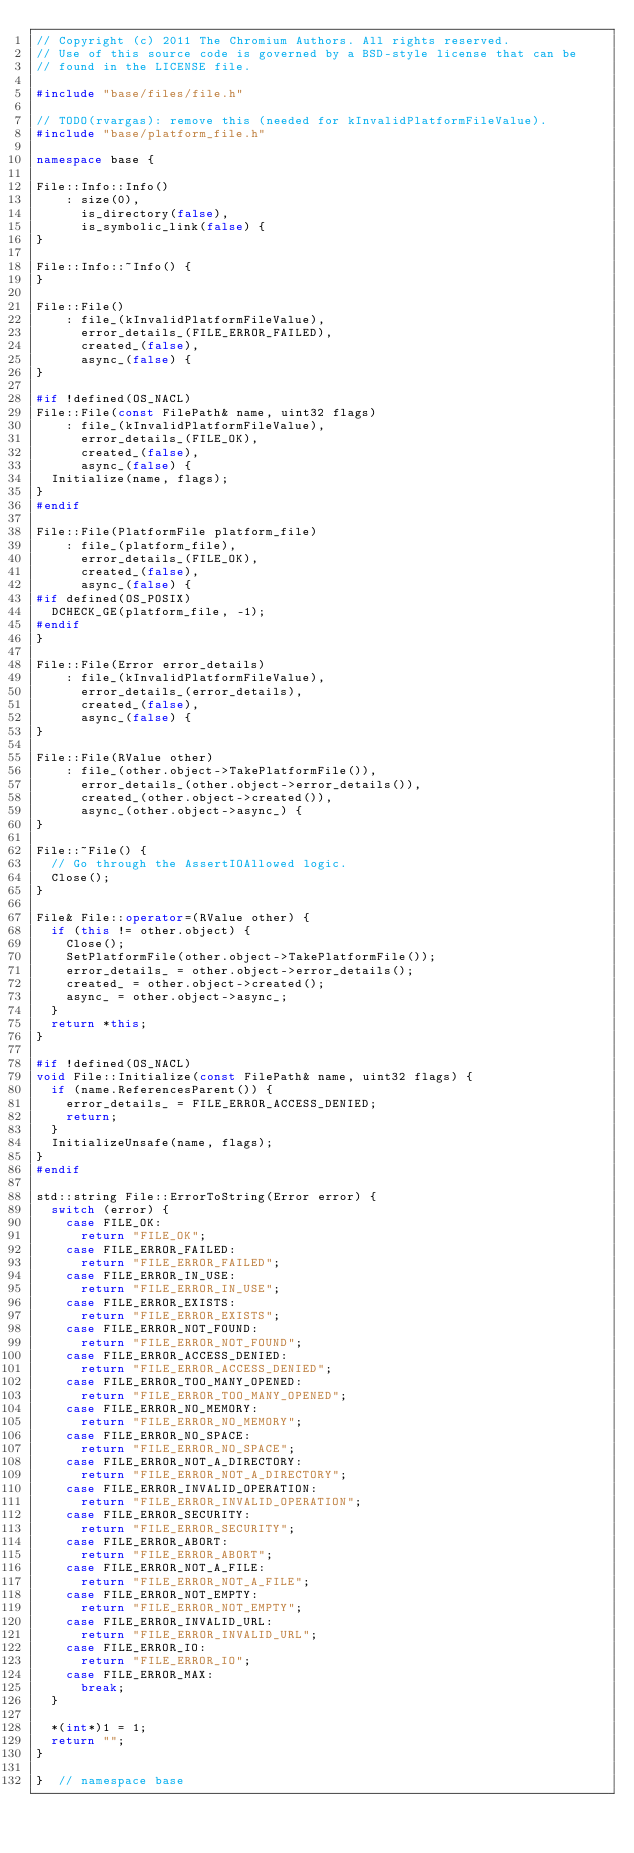<code> <loc_0><loc_0><loc_500><loc_500><_C++_>// Copyright (c) 2011 The Chromium Authors. All rights reserved.
// Use of this source code is governed by a BSD-style license that can be
// found in the LICENSE file.

#include "base/files/file.h"

// TODO(rvargas): remove this (needed for kInvalidPlatformFileValue).
#include "base/platform_file.h"

namespace base {

File::Info::Info()
    : size(0),
      is_directory(false),
      is_symbolic_link(false) {
}

File::Info::~Info() {
}

File::File()
    : file_(kInvalidPlatformFileValue),
      error_details_(FILE_ERROR_FAILED),
      created_(false),
      async_(false) {
}

#if !defined(OS_NACL)
File::File(const FilePath& name, uint32 flags)
    : file_(kInvalidPlatformFileValue),
      error_details_(FILE_OK),
      created_(false),
      async_(false) {
  Initialize(name, flags);
}
#endif

File::File(PlatformFile platform_file)
    : file_(platform_file),
      error_details_(FILE_OK),
      created_(false),
      async_(false) {
#if defined(OS_POSIX)
  DCHECK_GE(platform_file, -1);
#endif
}

File::File(Error error_details)
    : file_(kInvalidPlatformFileValue),
      error_details_(error_details),
      created_(false),
      async_(false) {
}

File::File(RValue other)
    : file_(other.object->TakePlatformFile()),
      error_details_(other.object->error_details()),
      created_(other.object->created()),
      async_(other.object->async_) {
}

File::~File() {
  // Go through the AssertIOAllowed logic.
  Close();
}

File& File::operator=(RValue other) {
  if (this != other.object) {
    Close();
    SetPlatformFile(other.object->TakePlatformFile());
    error_details_ = other.object->error_details();
    created_ = other.object->created();
    async_ = other.object->async_;
  }
  return *this;
}

#if !defined(OS_NACL)
void File::Initialize(const FilePath& name, uint32 flags) {
  if (name.ReferencesParent()) {
    error_details_ = FILE_ERROR_ACCESS_DENIED;
    return;
  }
  InitializeUnsafe(name, flags);
}
#endif

std::string File::ErrorToString(Error error) {
  switch (error) {
    case FILE_OK:
      return "FILE_OK";
    case FILE_ERROR_FAILED:
      return "FILE_ERROR_FAILED";
    case FILE_ERROR_IN_USE:
      return "FILE_ERROR_IN_USE";
    case FILE_ERROR_EXISTS:
      return "FILE_ERROR_EXISTS";
    case FILE_ERROR_NOT_FOUND:
      return "FILE_ERROR_NOT_FOUND";
    case FILE_ERROR_ACCESS_DENIED:
      return "FILE_ERROR_ACCESS_DENIED";
    case FILE_ERROR_TOO_MANY_OPENED:
      return "FILE_ERROR_TOO_MANY_OPENED";
    case FILE_ERROR_NO_MEMORY:
      return "FILE_ERROR_NO_MEMORY";
    case FILE_ERROR_NO_SPACE:
      return "FILE_ERROR_NO_SPACE";
    case FILE_ERROR_NOT_A_DIRECTORY:
      return "FILE_ERROR_NOT_A_DIRECTORY";
    case FILE_ERROR_INVALID_OPERATION:
      return "FILE_ERROR_INVALID_OPERATION";
    case FILE_ERROR_SECURITY:
      return "FILE_ERROR_SECURITY";
    case FILE_ERROR_ABORT:
      return "FILE_ERROR_ABORT";
    case FILE_ERROR_NOT_A_FILE:
      return "FILE_ERROR_NOT_A_FILE";
    case FILE_ERROR_NOT_EMPTY:
      return "FILE_ERROR_NOT_EMPTY";
    case FILE_ERROR_INVALID_URL:
      return "FILE_ERROR_INVALID_URL";
    case FILE_ERROR_IO:
      return "FILE_ERROR_IO";
    case FILE_ERROR_MAX:
      break;
  }

  *(int*)1 = 1;
  return "";
}

}  // namespace base
</code> 